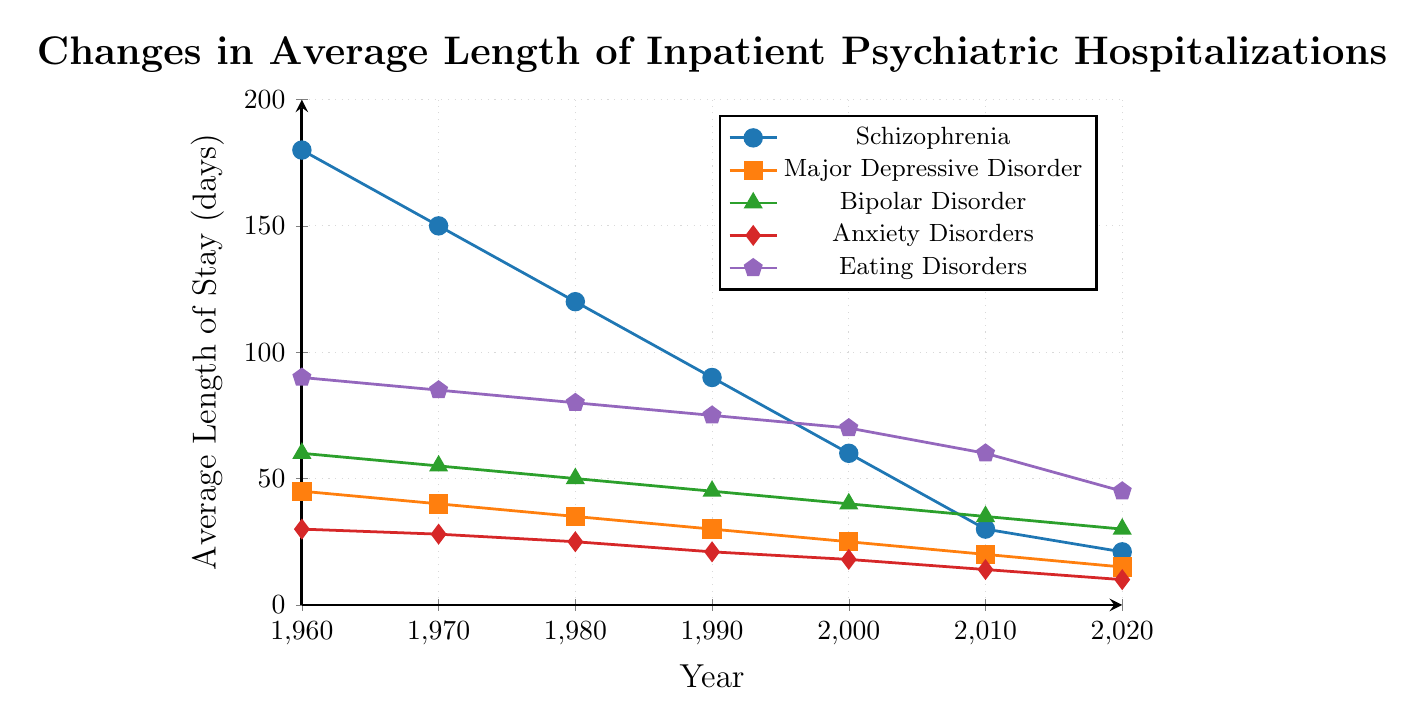Which disorder had the highest average length of stay in 1960? By observing the figure, the line for Schizophrenia starts at the highest point on the y-axis for the year 1960. Thus, the disorder with the highest average length of stay in 1960 is Schizophrenia.
Answer: Schizophrenia Which disorder shows the steepest decline in average length of stay from 1960 to 2020? Comparing the slopes of the lines, Schizophrenia's line drops the most dramatically from 180 days in 1960 to 21 days in 2020, indicating the steepest decline.
Answer: Schizophrenia What is the combined average length of stay for Major Depressive Disorder and Bipolar Disorder in 1990? From the figure, in 1990, Major Depressive Disorder is at 30 days, and Bipolar Disorder is at 45 days. Summing these up: 30 + 45 = 75 days.
Answer: 75 days During which decade did Anxiety Disorders see the largest decrease in average length of stay? By observing the figure, the steepest decline for Anxiety Disorders occurs between 1990 (21 days) and 2000 (18 days), a decrease of 7 days, compared to smaller decreases in other decades.
Answer: 1990s In 2010, which two disorders had the closest average length of stay, and what were their values? In 2010, the lines for Anxiety Disorders (14 days) and Eating Disorders (60 days) reflected different values, but the closest values are Schizophrenia (30 days) and Major Depressive Disorder (20 days).
Answer: Schizophrenia: 30, Major Depressive Disorder: 20 Which disorder's average length of stay remained above 40 days the longest? Examining the figure, Eating Disorders stayed above 40 days until the year 2020, longer than any other disorder.
Answer: Eating Disorders Between 1960 and 2020, what is the average annual rate of change in the length of stay for Schizophrenia? The average length of stay for Schizophrenia in 1960 is 180 days and in 2020 it is 21 days. The change is 180 - 21 = 159 days over 60 years. The average annual rate of change is 159/60 = 2.65 days per year.
Answer: 2.65 days per year 